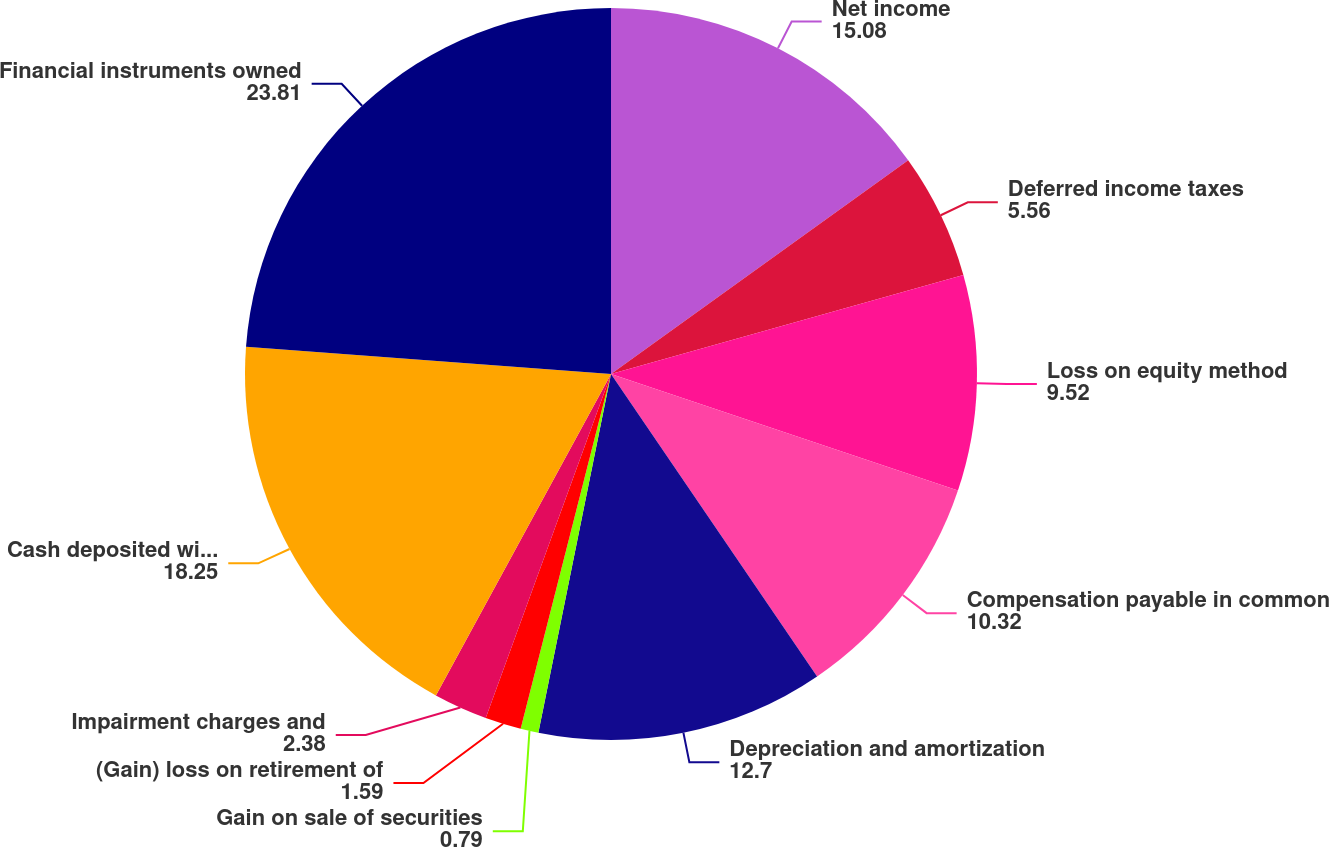Convert chart. <chart><loc_0><loc_0><loc_500><loc_500><pie_chart><fcel>Net income<fcel>Deferred income taxes<fcel>Loss on equity method<fcel>Compensation payable in common<fcel>Depreciation and amortization<fcel>Gain on sale of securities<fcel>(Gain) loss on retirement of<fcel>Impairment charges and<fcel>Cash deposited with clearing<fcel>Financial instruments owned<nl><fcel>15.08%<fcel>5.56%<fcel>9.52%<fcel>10.32%<fcel>12.7%<fcel>0.79%<fcel>1.59%<fcel>2.38%<fcel>18.25%<fcel>23.81%<nl></chart> 